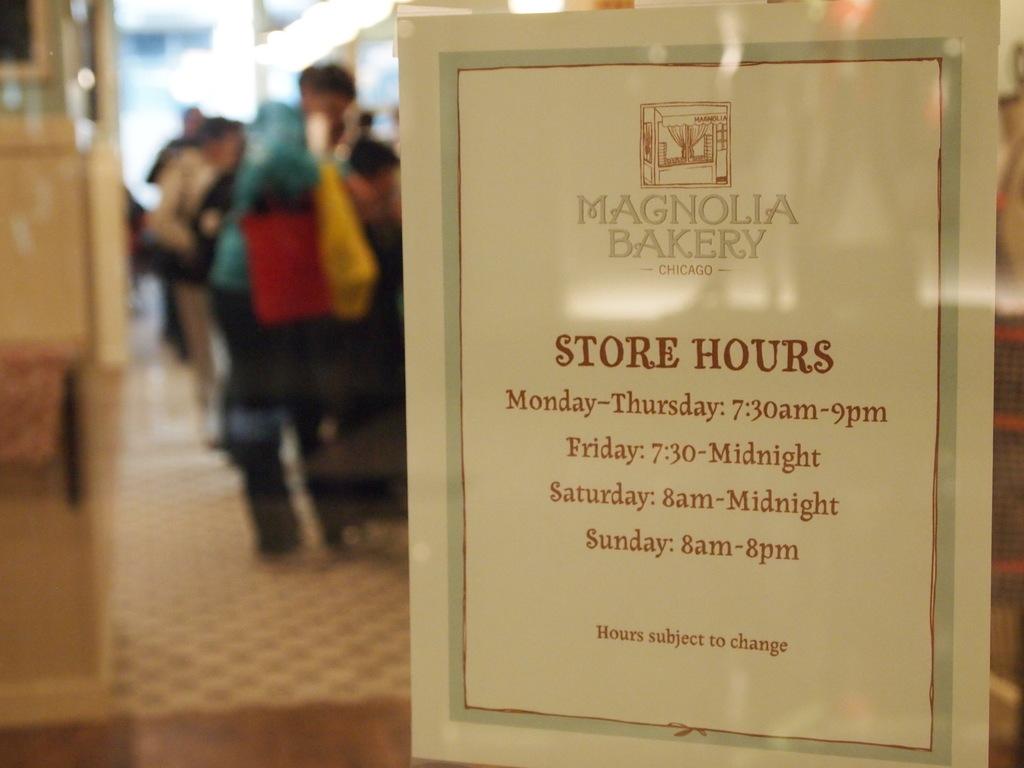What is the name of the bakery?
Give a very brief answer. Magnolia bakery. What are the store hours on sunday?
Your response must be concise. 8am-8pm. 